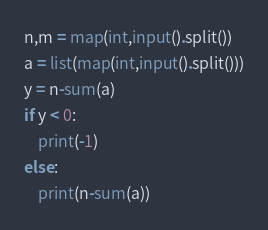<code> <loc_0><loc_0><loc_500><loc_500><_Python_>n,m = map(int,input().split())
a = list(map(int,input().split()))
y = n-sum(a)
if y < 0:
    print(-1)
else:
    print(n-sum(a))</code> 